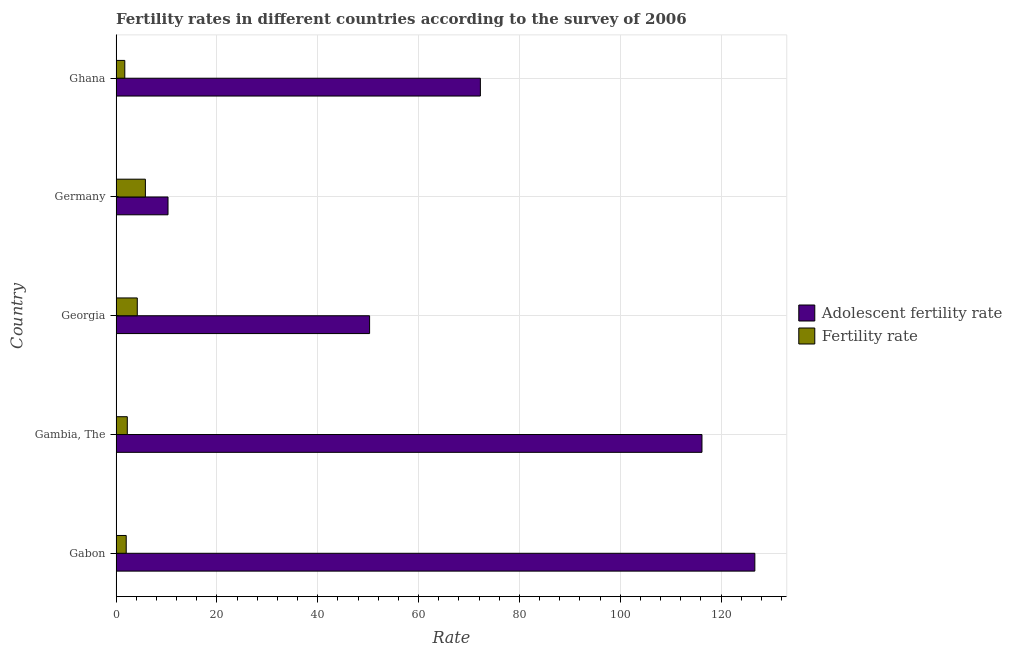How many different coloured bars are there?
Keep it short and to the point. 2. How many groups of bars are there?
Offer a terse response. 5. Are the number of bars per tick equal to the number of legend labels?
Give a very brief answer. Yes. Are the number of bars on each tick of the Y-axis equal?
Offer a terse response. Yes. How many bars are there on the 1st tick from the top?
Your answer should be very brief. 2. What is the label of the 2nd group of bars from the top?
Your answer should be very brief. Germany. In how many cases, is the number of bars for a given country not equal to the number of legend labels?
Keep it short and to the point. 0. What is the adolescent fertility rate in Germany?
Offer a terse response. 10.29. Across all countries, what is the maximum fertility rate?
Make the answer very short. 5.8. Across all countries, what is the minimum fertility rate?
Keep it short and to the point. 1.72. In which country was the adolescent fertility rate maximum?
Offer a terse response. Gabon. In which country was the adolescent fertility rate minimum?
Keep it short and to the point. Germany. What is the total fertility rate in the graph?
Make the answer very short. 15.93. What is the difference between the fertility rate in Germany and that in Ghana?
Make the answer very short. 4.08. What is the difference between the fertility rate in Georgia and the adolescent fertility rate in Gabon?
Offer a terse response. -122.49. What is the average fertility rate per country?
Provide a succinct answer. 3.19. What is the difference between the fertility rate and adolescent fertility rate in Gambia, The?
Keep it short and to the point. -113.99. What is the ratio of the adolescent fertility rate in Gabon to that in Germany?
Provide a short and direct response. 12.31. Is the difference between the adolescent fertility rate in Gambia, The and Germany greater than the difference between the fertility rate in Gambia, The and Germany?
Provide a short and direct response. Yes. What is the difference between the highest and the second highest fertility rate?
Provide a short and direct response. 1.61. What is the difference between the highest and the lowest adolescent fertility rate?
Your answer should be very brief. 116.4. In how many countries, is the fertility rate greater than the average fertility rate taken over all countries?
Your answer should be compact. 2. What does the 2nd bar from the top in Georgia represents?
Provide a succinct answer. Adolescent fertility rate. What does the 1st bar from the bottom in Ghana represents?
Give a very brief answer. Adolescent fertility rate. Are all the bars in the graph horizontal?
Ensure brevity in your answer.  Yes. What is the difference between two consecutive major ticks on the X-axis?
Your response must be concise. 20. Are the values on the major ticks of X-axis written in scientific E-notation?
Make the answer very short. No. Does the graph contain grids?
Provide a succinct answer. Yes. How many legend labels are there?
Provide a short and direct response. 2. How are the legend labels stacked?
Keep it short and to the point. Vertical. What is the title of the graph?
Ensure brevity in your answer.  Fertility rates in different countries according to the survey of 2006. Does "Age 65(female)" appear as one of the legend labels in the graph?
Offer a very short reply. No. What is the label or title of the X-axis?
Provide a succinct answer. Rate. What is the label or title of the Y-axis?
Offer a very short reply. Country. What is the Rate of Adolescent fertility rate in Gabon?
Your response must be concise. 126.69. What is the Rate in Adolescent fertility rate in Gambia, The?
Your response must be concise. 116.2. What is the Rate of Fertility rate in Gambia, The?
Keep it short and to the point. 2.22. What is the Rate of Adolescent fertility rate in Georgia?
Make the answer very short. 50.27. What is the Rate of Fertility rate in Georgia?
Make the answer very short. 4.19. What is the Rate of Adolescent fertility rate in Germany?
Give a very brief answer. 10.29. What is the Rate of Fertility rate in Germany?
Make the answer very short. 5.8. What is the Rate in Adolescent fertility rate in Ghana?
Give a very brief answer. 72.25. What is the Rate in Fertility rate in Ghana?
Offer a very short reply. 1.72. Across all countries, what is the maximum Rate of Adolescent fertility rate?
Offer a very short reply. 126.69. Across all countries, what is the maximum Rate of Fertility rate?
Your answer should be compact. 5.8. Across all countries, what is the minimum Rate in Adolescent fertility rate?
Offer a very short reply. 10.29. Across all countries, what is the minimum Rate of Fertility rate?
Provide a short and direct response. 1.72. What is the total Rate in Adolescent fertility rate in the graph?
Your response must be concise. 375.7. What is the total Rate of Fertility rate in the graph?
Provide a short and direct response. 15.93. What is the difference between the Rate of Adolescent fertility rate in Gabon and that in Gambia, The?
Give a very brief answer. 10.49. What is the difference between the Rate in Fertility rate in Gabon and that in Gambia, The?
Offer a terse response. -0.22. What is the difference between the Rate of Adolescent fertility rate in Gabon and that in Georgia?
Offer a terse response. 76.41. What is the difference between the Rate of Fertility rate in Gabon and that in Georgia?
Make the answer very short. -2.19. What is the difference between the Rate in Adolescent fertility rate in Gabon and that in Germany?
Your response must be concise. 116.4. What is the difference between the Rate in Fertility rate in Gabon and that in Germany?
Ensure brevity in your answer.  -3.8. What is the difference between the Rate in Adolescent fertility rate in Gabon and that in Ghana?
Your answer should be compact. 54.44. What is the difference between the Rate in Fertility rate in Gabon and that in Ghana?
Offer a terse response. 0.28. What is the difference between the Rate of Adolescent fertility rate in Gambia, The and that in Georgia?
Offer a very short reply. 65.93. What is the difference between the Rate in Fertility rate in Gambia, The and that in Georgia?
Your response must be concise. -1.98. What is the difference between the Rate in Adolescent fertility rate in Gambia, The and that in Germany?
Offer a terse response. 105.91. What is the difference between the Rate in Fertility rate in Gambia, The and that in Germany?
Offer a very short reply. -3.59. What is the difference between the Rate of Adolescent fertility rate in Gambia, The and that in Ghana?
Give a very brief answer. 43.95. What is the difference between the Rate of Fertility rate in Gambia, The and that in Ghana?
Ensure brevity in your answer.  0.5. What is the difference between the Rate in Adolescent fertility rate in Georgia and that in Germany?
Make the answer very short. 39.98. What is the difference between the Rate in Fertility rate in Georgia and that in Germany?
Make the answer very short. -1.61. What is the difference between the Rate in Adolescent fertility rate in Georgia and that in Ghana?
Provide a short and direct response. -21.97. What is the difference between the Rate in Fertility rate in Georgia and that in Ghana?
Keep it short and to the point. 2.48. What is the difference between the Rate of Adolescent fertility rate in Germany and that in Ghana?
Give a very brief answer. -61.96. What is the difference between the Rate in Fertility rate in Germany and that in Ghana?
Give a very brief answer. 4.08. What is the difference between the Rate in Adolescent fertility rate in Gabon and the Rate in Fertility rate in Gambia, The?
Keep it short and to the point. 124.47. What is the difference between the Rate of Adolescent fertility rate in Gabon and the Rate of Fertility rate in Georgia?
Your answer should be compact. 122.49. What is the difference between the Rate in Adolescent fertility rate in Gabon and the Rate in Fertility rate in Germany?
Your answer should be compact. 120.88. What is the difference between the Rate of Adolescent fertility rate in Gabon and the Rate of Fertility rate in Ghana?
Provide a succinct answer. 124.97. What is the difference between the Rate in Adolescent fertility rate in Gambia, The and the Rate in Fertility rate in Georgia?
Your answer should be compact. 112.01. What is the difference between the Rate in Adolescent fertility rate in Gambia, The and the Rate in Fertility rate in Germany?
Provide a short and direct response. 110.4. What is the difference between the Rate in Adolescent fertility rate in Gambia, The and the Rate in Fertility rate in Ghana?
Give a very brief answer. 114.48. What is the difference between the Rate of Adolescent fertility rate in Georgia and the Rate of Fertility rate in Germany?
Make the answer very short. 44.47. What is the difference between the Rate of Adolescent fertility rate in Georgia and the Rate of Fertility rate in Ghana?
Offer a terse response. 48.56. What is the difference between the Rate in Adolescent fertility rate in Germany and the Rate in Fertility rate in Ghana?
Ensure brevity in your answer.  8.57. What is the average Rate in Adolescent fertility rate per country?
Your answer should be compact. 75.14. What is the average Rate in Fertility rate per country?
Provide a short and direct response. 3.19. What is the difference between the Rate in Adolescent fertility rate and Rate in Fertility rate in Gabon?
Make the answer very short. 124.69. What is the difference between the Rate in Adolescent fertility rate and Rate in Fertility rate in Gambia, The?
Keep it short and to the point. 113.99. What is the difference between the Rate of Adolescent fertility rate and Rate of Fertility rate in Georgia?
Offer a terse response. 46.08. What is the difference between the Rate in Adolescent fertility rate and Rate in Fertility rate in Germany?
Your answer should be very brief. 4.49. What is the difference between the Rate in Adolescent fertility rate and Rate in Fertility rate in Ghana?
Offer a very short reply. 70.53. What is the ratio of the Rate in Adolescent fertility rate in Gabon to that in Gambia, The?
Provide a succinct answer. 1.09. What is the ratio of the Rate of Fertility rate in Gabon to that in Gambia, The?
Provide a short and direct response. 0.9. What is the ratio of the Rate in Adolescent fertility rate in Gabon to that in Georgia?
Offer a very short reply. 2.52. What is the ratio of the Rate in Fertility rate in Gabon to that in Georgia?
Provide a short and direct response. 0.48. What is the ratio of the Rate in Adolescent fertility rate in Gabon to that in Germany?
Provide a succinct answer. 12.31. What is the ratio of the Rate in Fertility rate in Gabon to that in Germany?
Offer a terse response. 0.34. What is the ratio of the Rate of Adolescent fertility rate in Gabon to that in Ghana?
Offer a terse response. 1.75. What is the ratio of the Rate of Fertility rate in Gabon to that in Ghana?
Offer a very short reply. 1.16. What is the ratio of the Rate in Adolescent fertility rate in Gambia, The to that in Georgia?
Make the answer very short. 2.31. What is the ratio of the Rate in Fertility rate in Gambia, The to that in Georgia?
Offer a terse response. 0.53. What is the ratio of the Rate in Adolescent fertility rate in Gambia, The to that in Germany?
Your response must be concise. 11.29. What is the ratio of the Rate in Fertility rate in Gambia, The to that in Germany?
Keep it short and to the point. 0.38. What is the ratio of the Rate of Adolescent fertility rate in Gambia, The to that in Ghana?
Offer a very short reply. 1.61. What is the ratio of the Rate in Fertility rate in Gambia, The to that in Ghana?
Your answer should be very brief. 1.29. What is the ratio of the Rate in Adolescent fertility rate in Georgia to that in Germany?
Provide a short and direct response. 4.89. What is the ratio of the Rate of Fertility rate in Georgia to that in Germany?
Offer a very short reply. 0.72. What is the ratio of the Rate of Adolescent fertility rate in Georgia to that in Ghana?
Your answer should be very brief. 0.7. What is the ratio of the Rate in Fertility rate in Georgia to that in Ghana?
Your answer should be compact. 2.44. What is the ratio of the Rate in Adolescent fertility rate in Germany to that in Ghana?
Your answer should be very brief. 0.14. What is the ratio of the Rate of Fertility rate in Germany to that in Ghana?
Make the answer very short. 3.38. What is the difference between the highest and the second highest Rate in Adolescent fertility rate?
Make the answer very short. 10.49. What is the difference between the highest and the second highest Rate of Fertility rate?
Your answer should be very brief. 1.61. What is the difference between the highest and the lowest Rate of Adolescent fertility rate?
Offer a very short reply. 116.4. What is the difference between the highest and the lowest Rate of Fertility rate?
Your response must be concise. 4.08. 